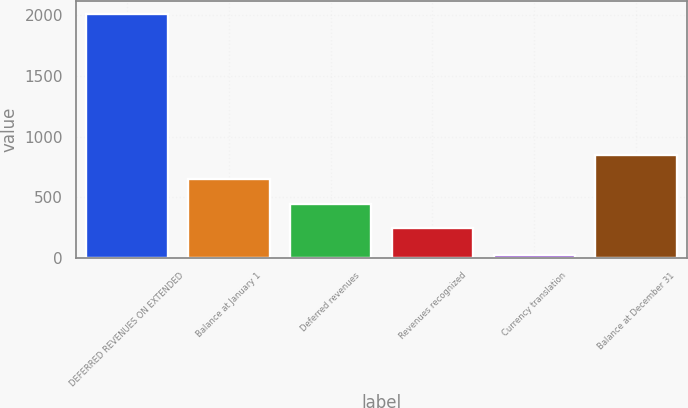Convert chart. <chart><loc_0><loc_0><loc_500><loc_500><bar_chart><fcel>DEFERRED REVENUES ON EXTENDED<fcel>Balance at January 1<fcel>Deferred revenues<fcel>Revenues recognized<fcel>Currency translation<fcel>Balance at December 31<nl><fcel>2015<fcel>647.04<fcel>447.72<fcel>248.4<fcel>21.8<fcel>846.36<nl></chart> 